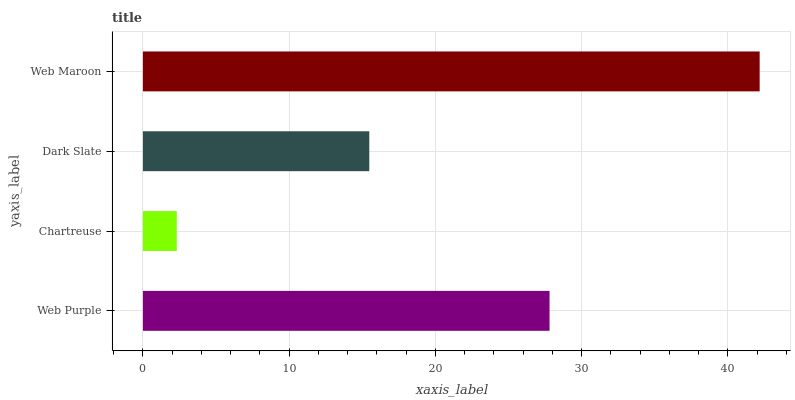Is Chartreuse the minimum?
Answer yes or no. Yes. Is Web Maroon the maximum?
Answer yes or no. Yes. Is Dark Slate the minimum?
Answer yes or no. No. Is Dark Slate the maximum?
Answer yes or no. No. Is Dark Slate greater than Chartreuse?
Answer yes or no. Yes. Is Chartreuse less than Dark Slate?
Answer yes or no. Yes. Is Chartreuse greater than Dark Slate?
Answer yes or no. No. Is Dark Slate less than Chartreuse?
Answer yes or no. No. Is Web Purple the high median?
Answer yes or no. Yes. Is Dark Slate the low median?
Answer yes or no. Yes. Is Chartreuse the high median?
Answer yes or no. No. Is Web Maroon the low median?
Answer yes or no. No. 